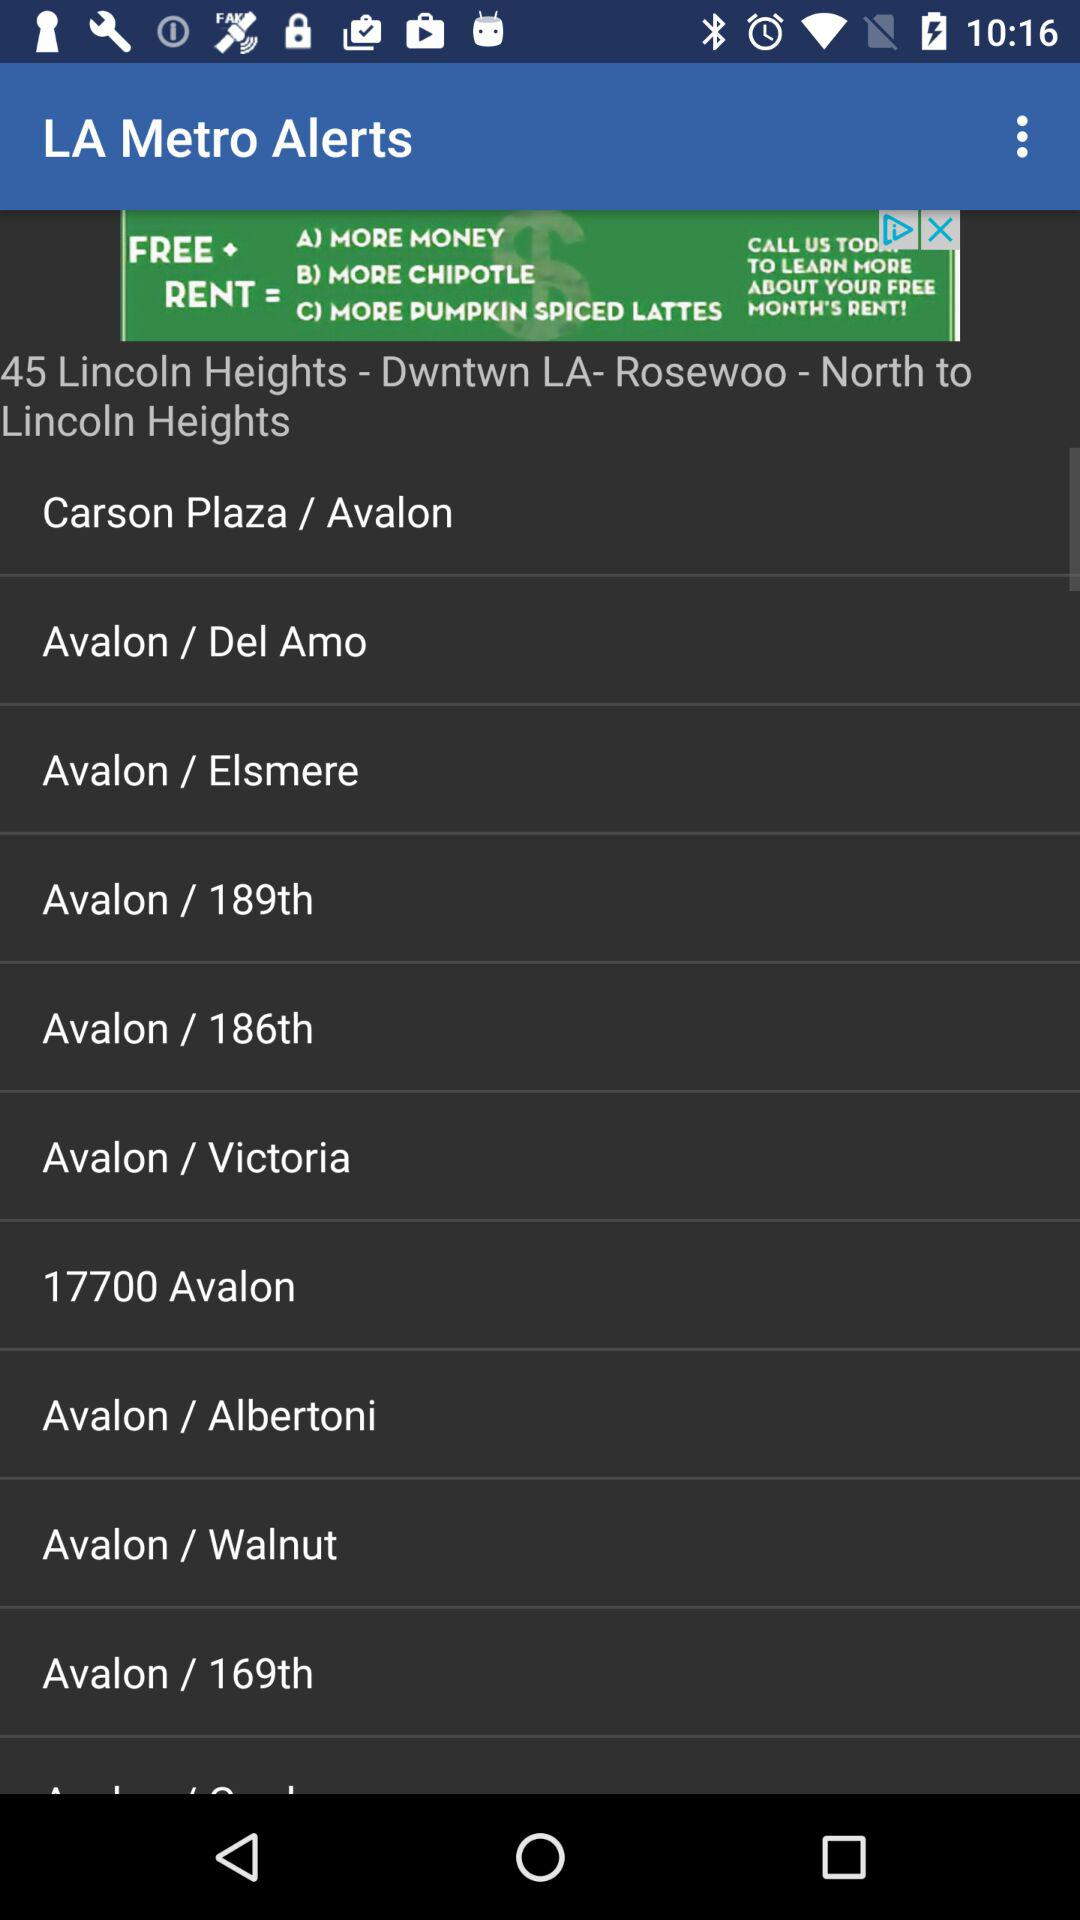How many stops are there on the 45 Lincoln Heights - Dwntwn LA- Rosewoo - North to Lincoln Heights route?
Answer the question using a single word or phrase. 11 